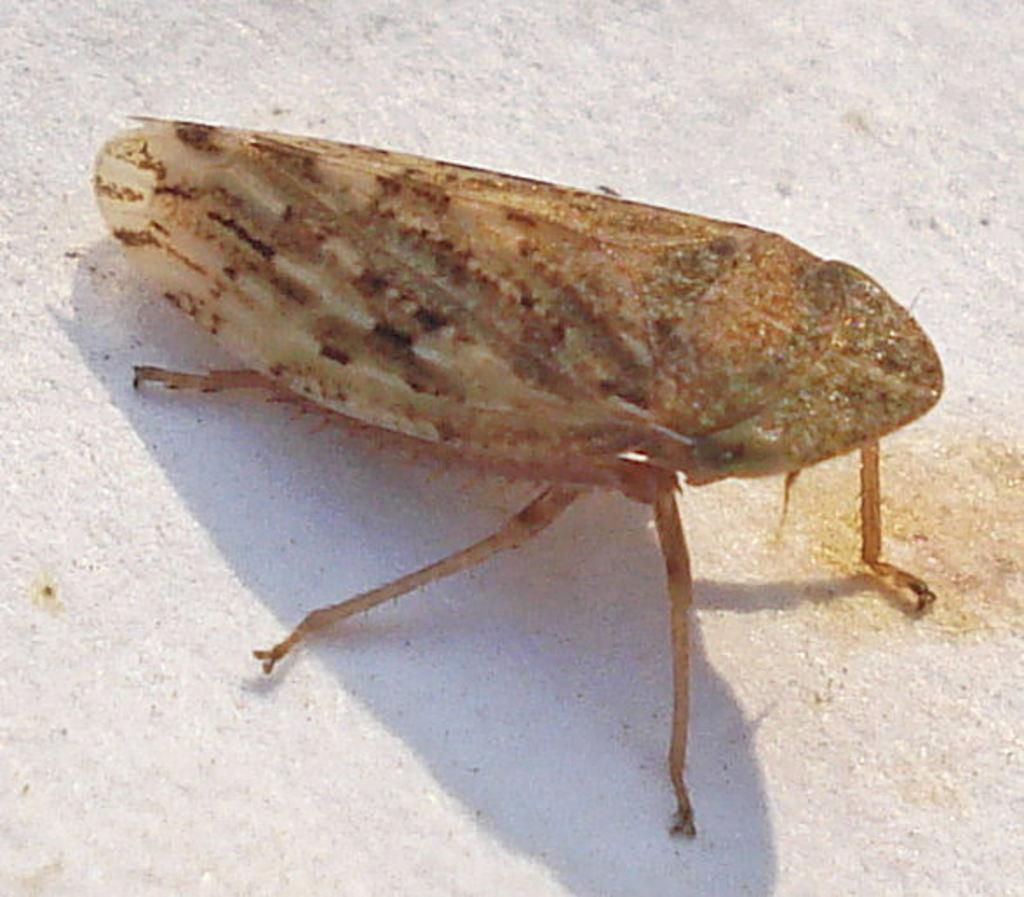What type of creature is present in the image? There is an insect in the image. Can you describe the insect's location in the image? The insect is on a surface in the image. What type of star can be seen in the basket in the image? There is no star or basket present in the image; it only features an insect on a surface. 